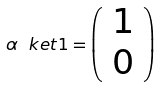Convert formula to latex. <formula><loc_0><loc_0><loc_500><loc_500>\alpha \ k e t { 1 } = \left ( \begin{array} { c } 1 \\ 0 \end{array} \right )</formula> 